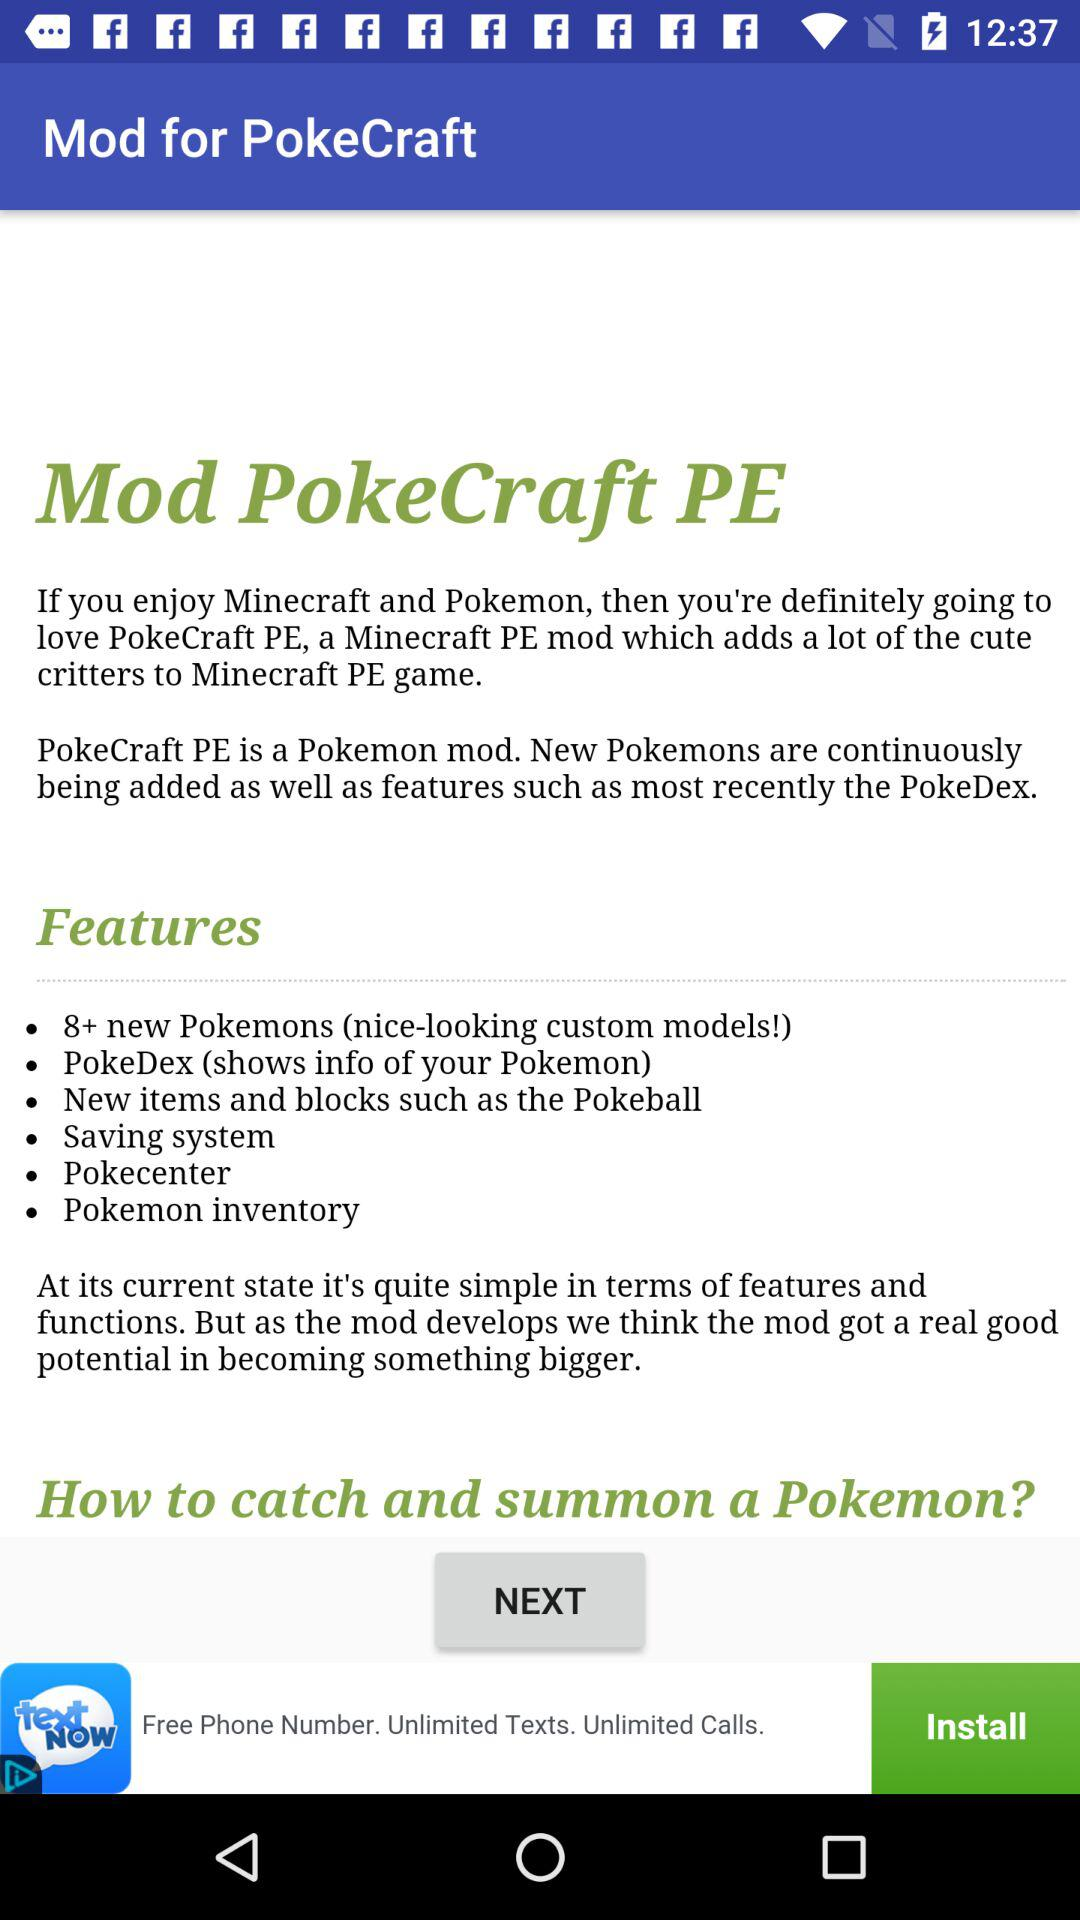What are the features of Mod PokeCraft PE? The features of Mod PokeCraft PE are: "8+ new Pokemons (nice-looking custom models!)", "Pokedex (shows info of your Pokemon)", "New items and blocks such as the Pokeball", "Saving system", "Pokecenter", and "Pokemon inventory". 